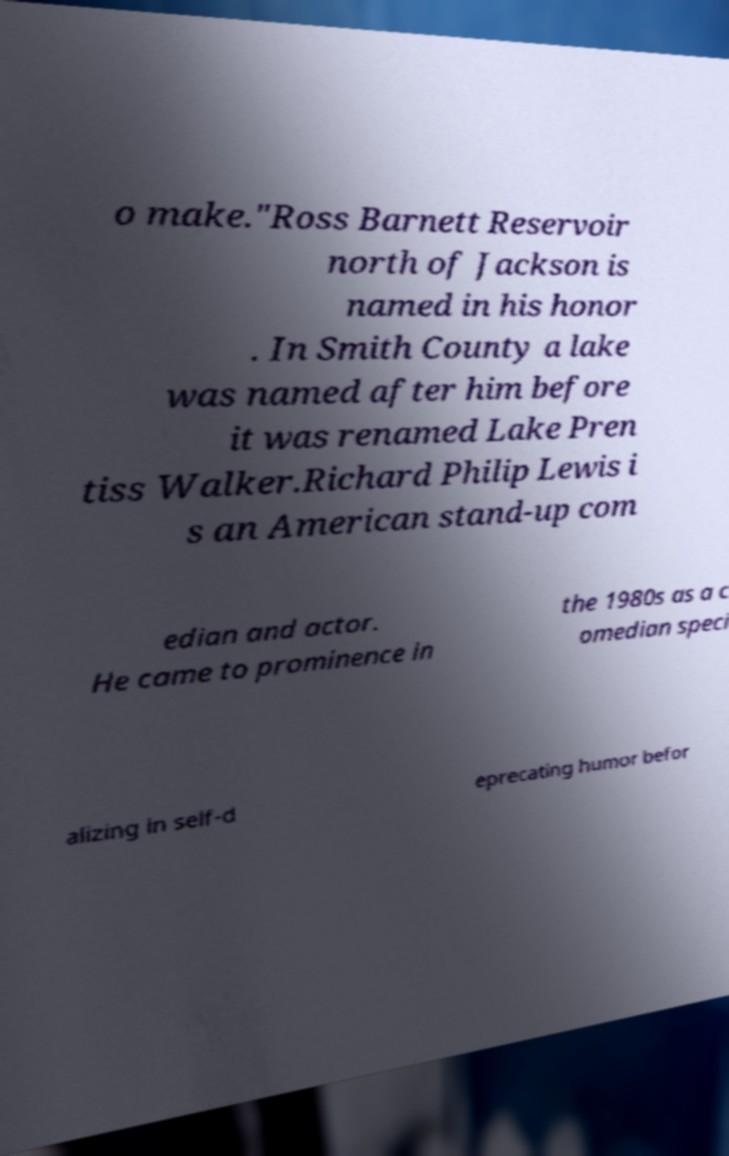Could you assist in decoding the text presented in this image and type it out clearly? o make."Ross Barnett Reservoir north of Jackson is named in his honor . In Smith County a lake was named after him before it was renamed Lake Pren tiss Walker.Richard Philip Lewis i s an American stand-up com edian and actor. He came to prominence in the 1980s as a c omedian speci alizing in self-d eprecating humor befor 